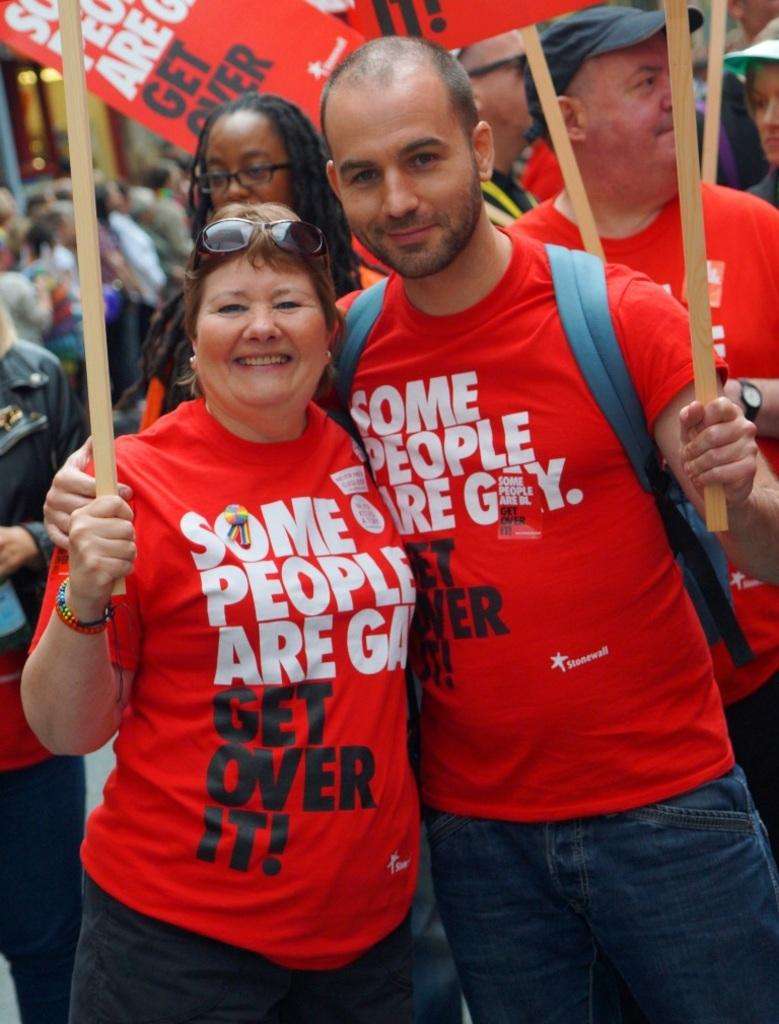How many persons are visible in the image? There are persons in the image, but the exact number cannot be determined from the provided facts. What are the sticks used for in the image? The purpose of the sticks in the image cannot be determined from the provided facts. What other objects can be seen in the image besides the persons and sticks? There are other objects in the image, but their specific nature cannot be determined from the provided facts. Can you describe the background of the image? In the background of the image, there are persons, lights, and other objects. What might the lights be used for in the background of the image? The purpose of the lights in the background of the image cannot be determined from the provided facts. Where is the nest located in the image? There is no nest present in the image. 